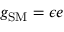<formula> <loc_0><loc_0><loc_500><loc_500>g _ { S M } = \epsilon e</formula> 